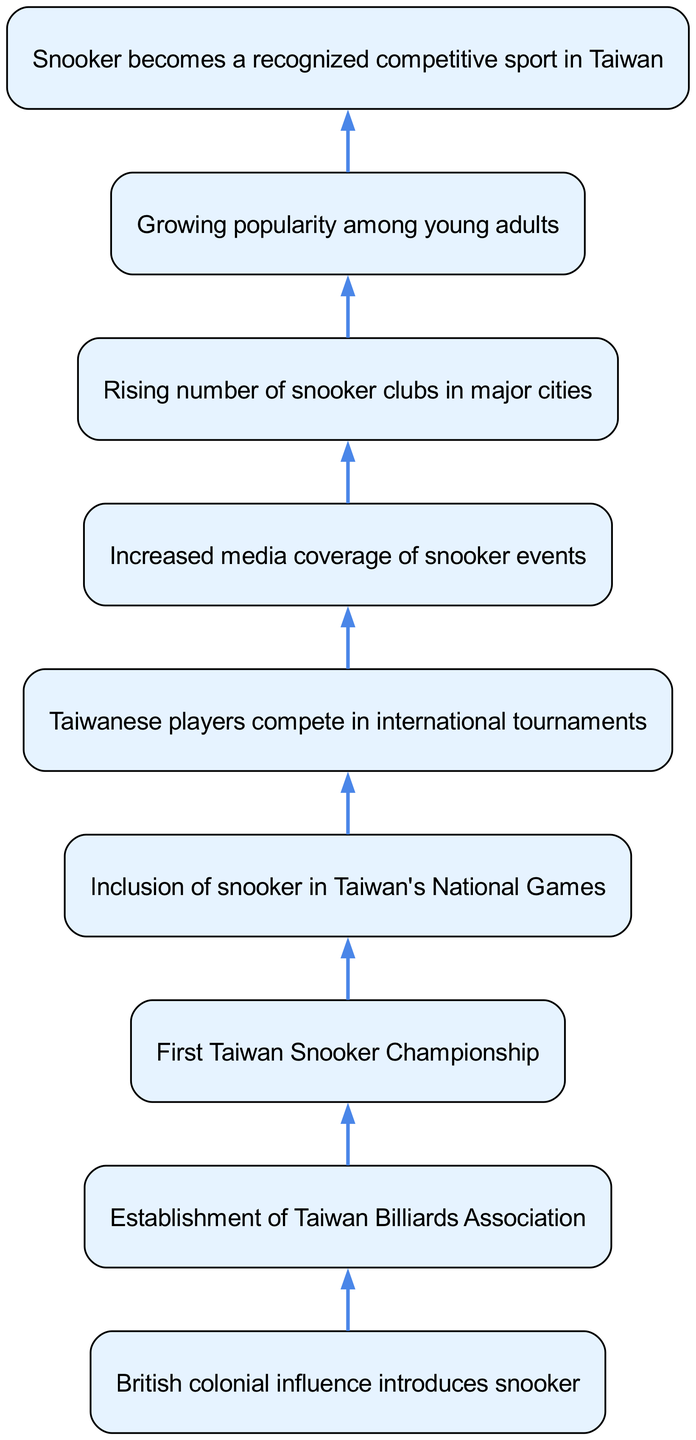What was the first event related to snooker in Taiwan? The diagram indicates that the first significant event was the "British colonial influence introduces snooker," showcasing the introduction of the sport to Taiwan.
Answer: British colonial influence introduces snooker How many connections are there in the diagram? By counting the lines that connect elements, there are a total of eight connections listed in the diagram.
Answer: 8 What leads to the establishment of more snooker clubs in major cities? The flow shows that increased media coverage of snooker events leads to a rising number of snooker clubs, linking media impact to club establishment.
Answer: Increased media coverage of snooker events What is one key factor in making snooker a recognized competitive sport in Taiwan? The diagram illustrates that Taiwanese players competing in international tournaments is a critical step towards recognition as a competitive sport.
Answer: Taiwanese players compete in international tournaments In what stage did snooker become part of Taiwan's National Games? The diagram shows that after the first Taiwan Snooker Championship, the next step was the inclusion of snooker in Taiwan's National Games, indicating its growing status.
Answer: Inclusion of snooker in Taiwan's National Games What influences the growing popularity of snooker among young adults? The rising number of snooker clubs in major cities provides opportunities for young adults to engage in the sport, which promotes its popularity among that demographic.
Answer: Rising number of snooker clubs in major cities What was established after the introduction of snooker to Taiwan? The diagram flows from the introduction to the establishment of the "Taiwan Billiards Association," indicating the organizational development that followed.
Answer: Establishment of Taiwan Billiards Association How does media coverage correlate with the number of snooker clubs? The flow shows that the increase in media coverage directly leads to the rising number of snooker clubs, suggesting a positive feedback loop between visibility and participation.
Answer: Increased media coverage of snooker events 